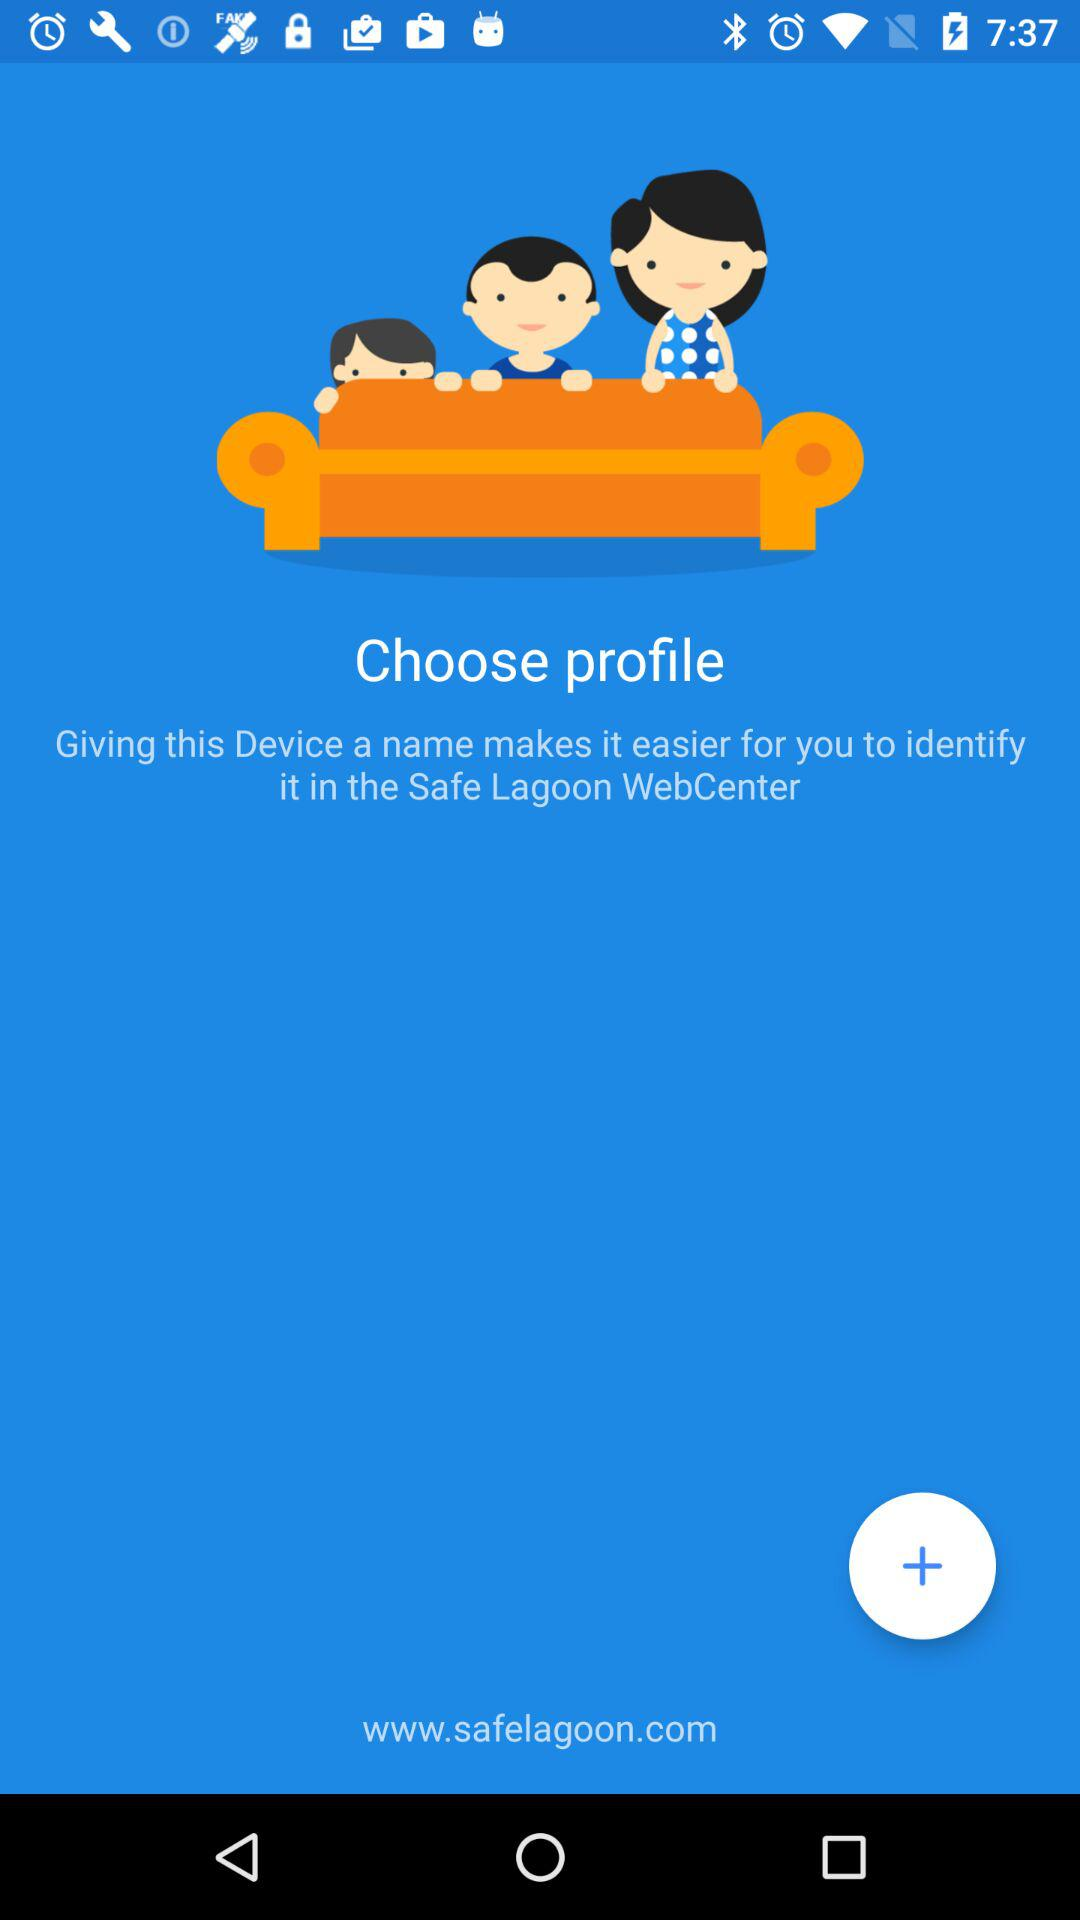What is the name of the application? The name of the application is "Safe Lagoon". 